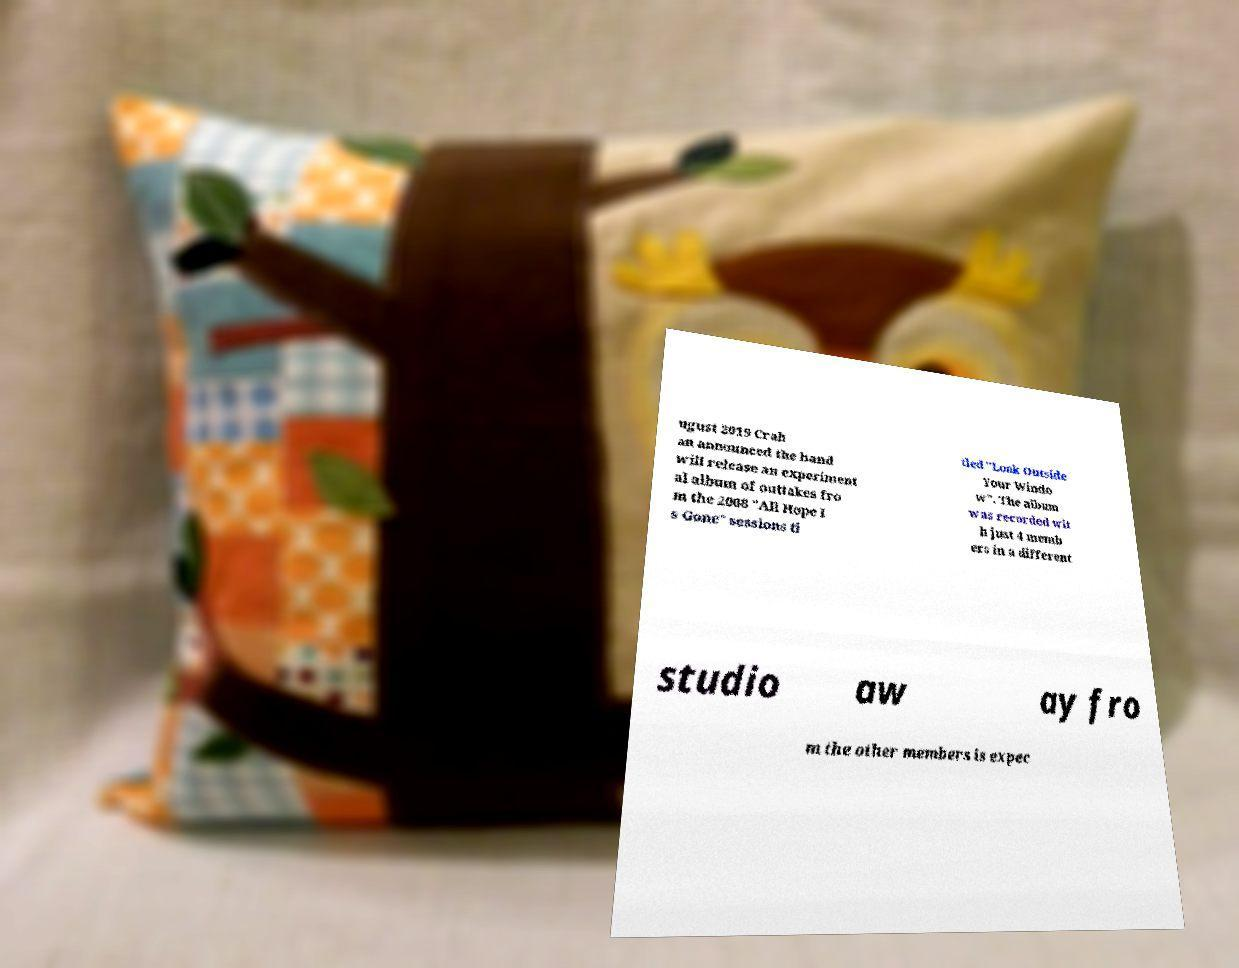What messages or text are displayed in this image? I need them in a readable, typed format. ugust 2019 Crah an announced the band will release an experiment al album of outtakes fro m the 2008 "All Hope I s Gone" sessions ti tled "Look Outside Your Windo w". The album was recorded wit h just 4 memb ers in a different studio aw ay fro m the other members is expec 